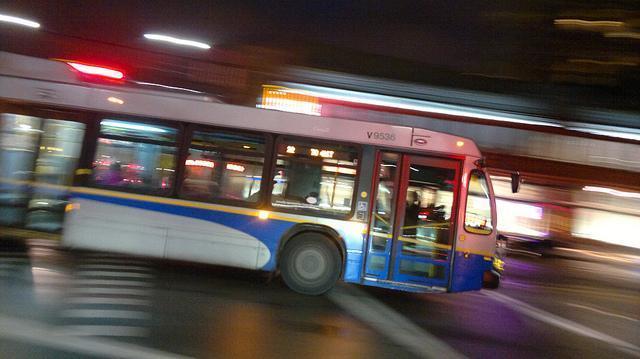How many wheels are in the picture?
Give a very brief answer. 1. How many buses are there?
Give a very brief answer. 1. 